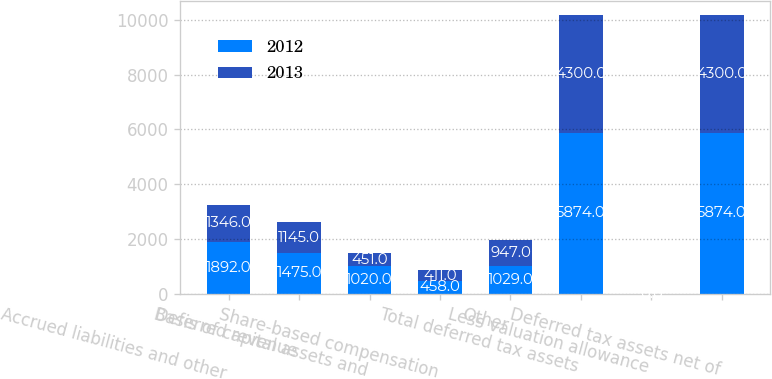Convert chart to OTSL. <chart><loc_0><loc_0><loc_500><loc_500><stacked_bar_chart><ecel><fcel>Accrued liabilities and other<fcel>Deferred revenue<fcel>Basis of capital assets and<fcel>Share-based compensation<fcel>Other<fcel>Total deferred tax assets<fcel>Less valuation allowance<fcel>Deferred tax assets net of<nl><fcel>2012<fcel>1892<fcel>1475<fcel>1020<fcel>458<fcel>1029<fcel>5874<fcel>0<fcel>5874<nl><fcel>2013<fcel>1346<fcel>1145<fcel>451<fcel>411<fcel>947<fcel>4300<fcel>0<fcel>4300<nl></chart> 